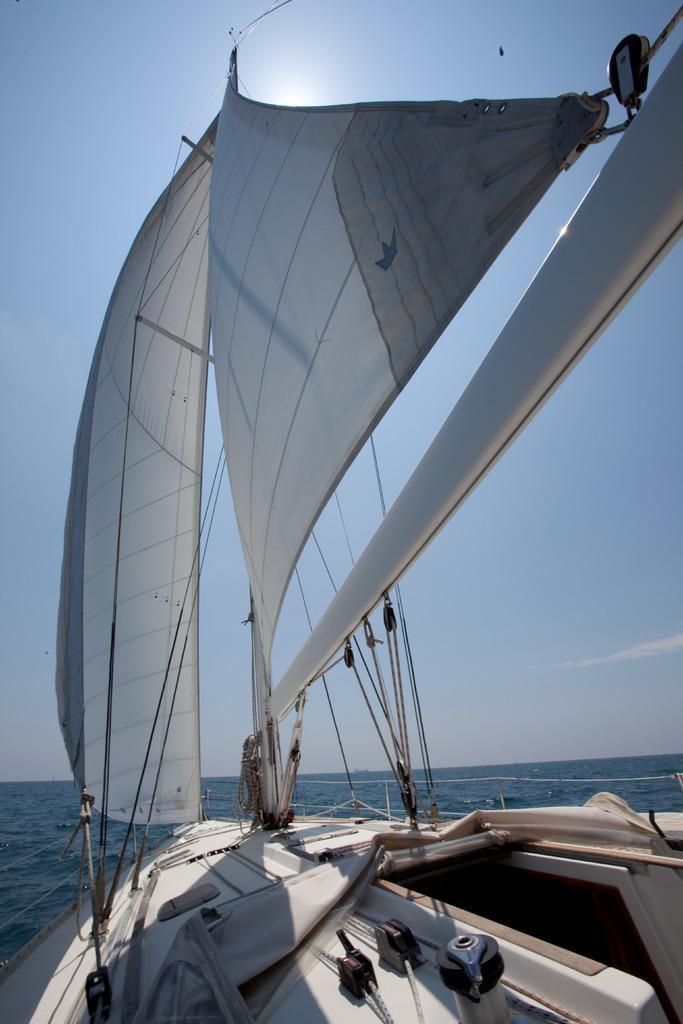Describe this image in one or two sentences. In this image, we can see a ship on the water and at the top, there is sky. 